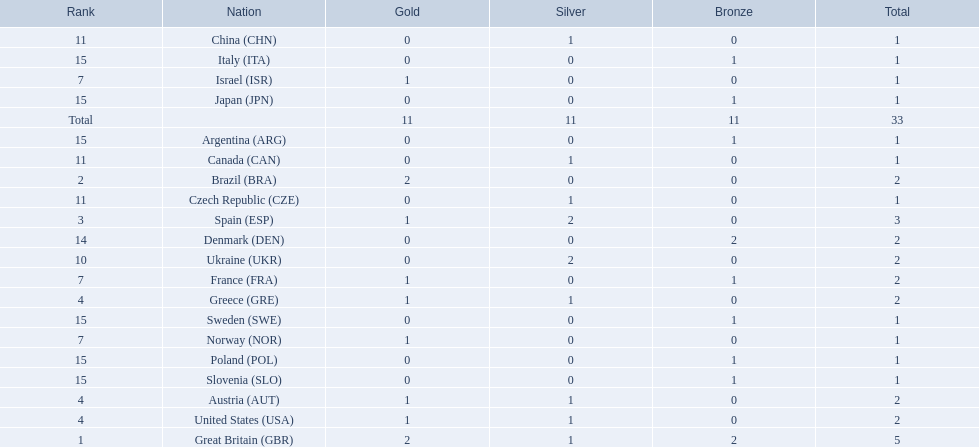What are all of the countries? Great Britain (GBR), Brazil (BRA), Spain (ESP), Austria (AUT), Greece (GRE), United States (USA), France (FRA), Israel (ISR), Norway (NOR), Ukraine (UKR), China (CHN), Czech Republic (CZE), Canada (CAN), Denmark (DEN), Argentina (ARG), Italy (ITA), Japan (JPN), Poland (POL), Slovenia (SLO), Sweden (SWE). Which ones earned a medal? Great Britain (GBR), Brazil (BRA), Spain (ESP), Austria (AUT), Greece (GRE), United States (USA), France (FRA), Israel (ISR), Norway (NOR), Ukraine (UKR), China (CHN), Czech Republic (CZE), Canada (CAN), Denmark (DEN), Argentina (ARG), Italy (ITA), Japan (JPN), Poland (POL), Slovenia (SLO), Sweden (SWE). Which countries earned at least 3 medals? Great Britain (GBR), Spain (ESP). Which country earned 3 medals? Spain (ESP). 